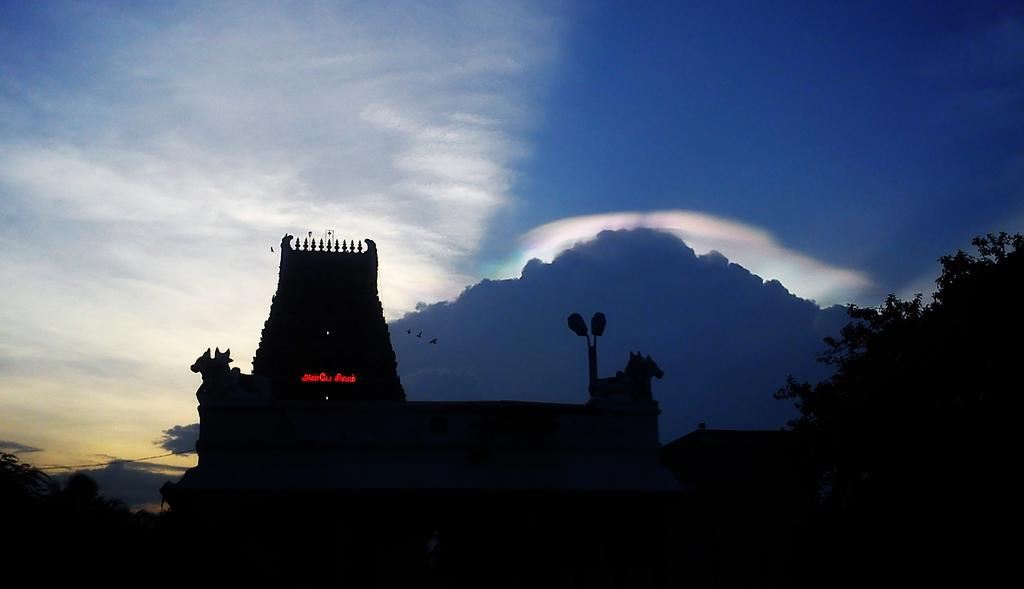What type of structure is visible in the image? There is a temple in the image. What can be seen on a pole in the image? There are lights on a pole in the image. What type of vegetation is present in the image? There are trees in the image. How would you describe the sky in the image? The sky is cloudy in the image. What is happening in the sky in the image? There are birds flying in the image. What is the mass of the edge of the temple in the image? The mass of the edge of the temple cannot be determined from the image, as mass is a measure of the amount of matter in an object and is not visible. 